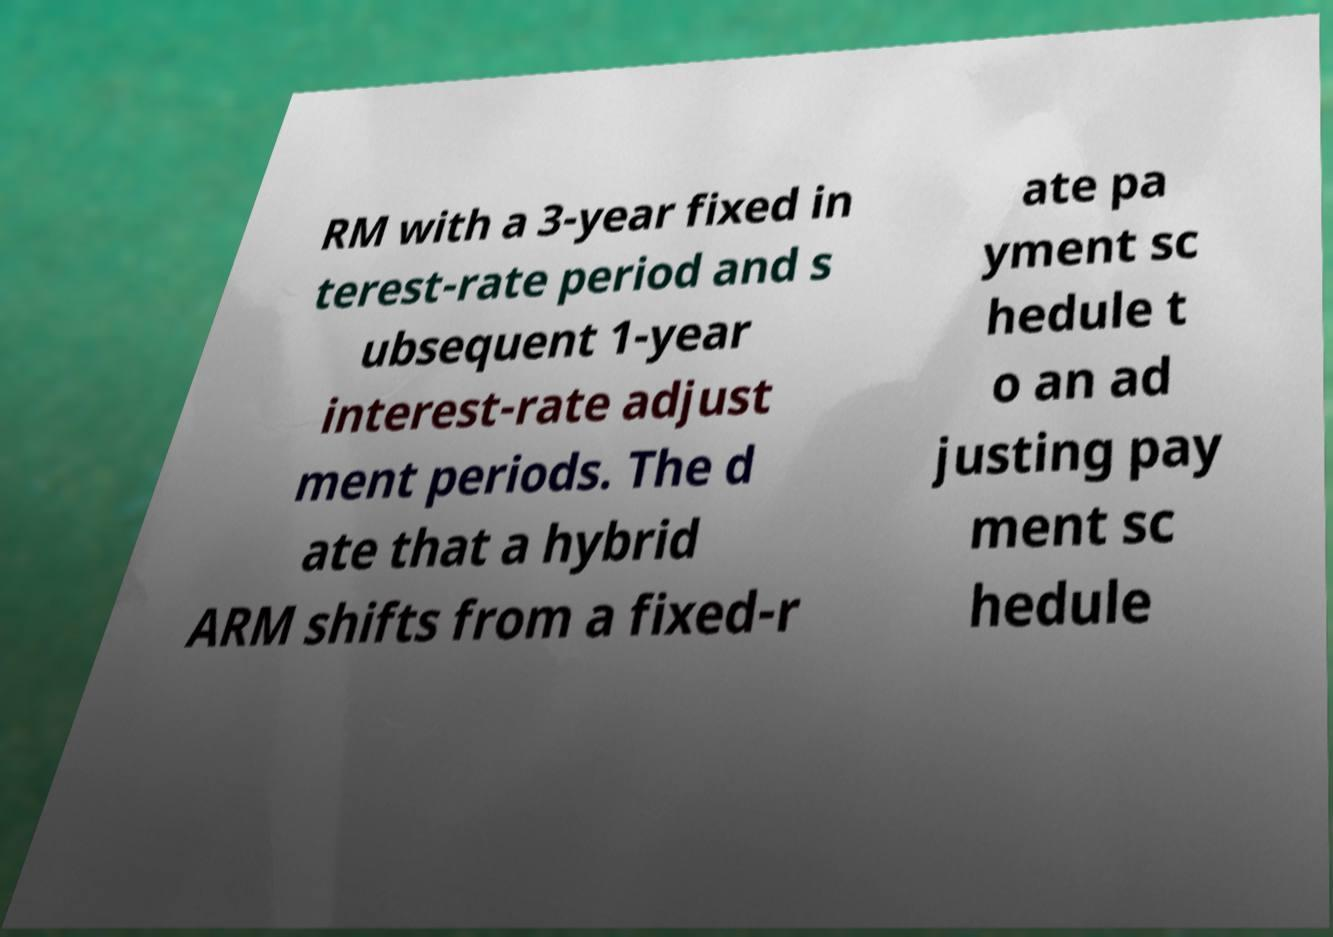Could you extract and type out the text from this image? RM with a 3-year fixed in terest-rate period and s ubsequent 1-year interest-rate adjust ment periods. The d ate that a hybrid ARM shifts from a fixed-r ate pa yment sc hedule t o an ad justing pay ment sc hedule 